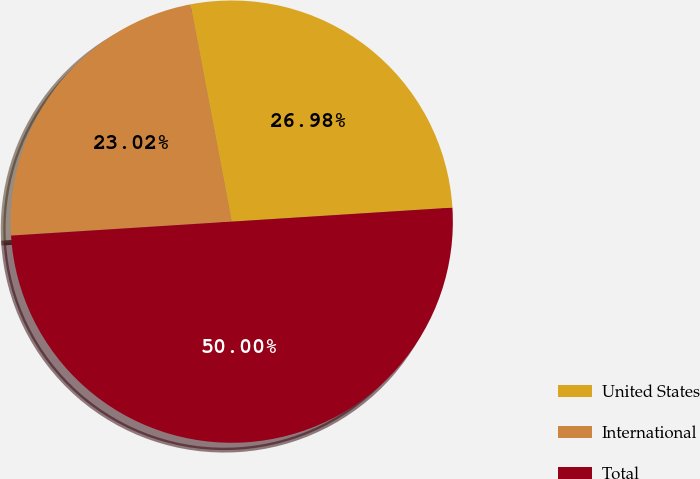Convert chart to OTSL. <chart><loc_0><loc_0><loc_500><loc_500><pie_chart><fcel>United States<fcel>International<fcel>Total<nl><fcel>26.98%<fcel>23.02%<fcel>50.0%<nl></chart> 